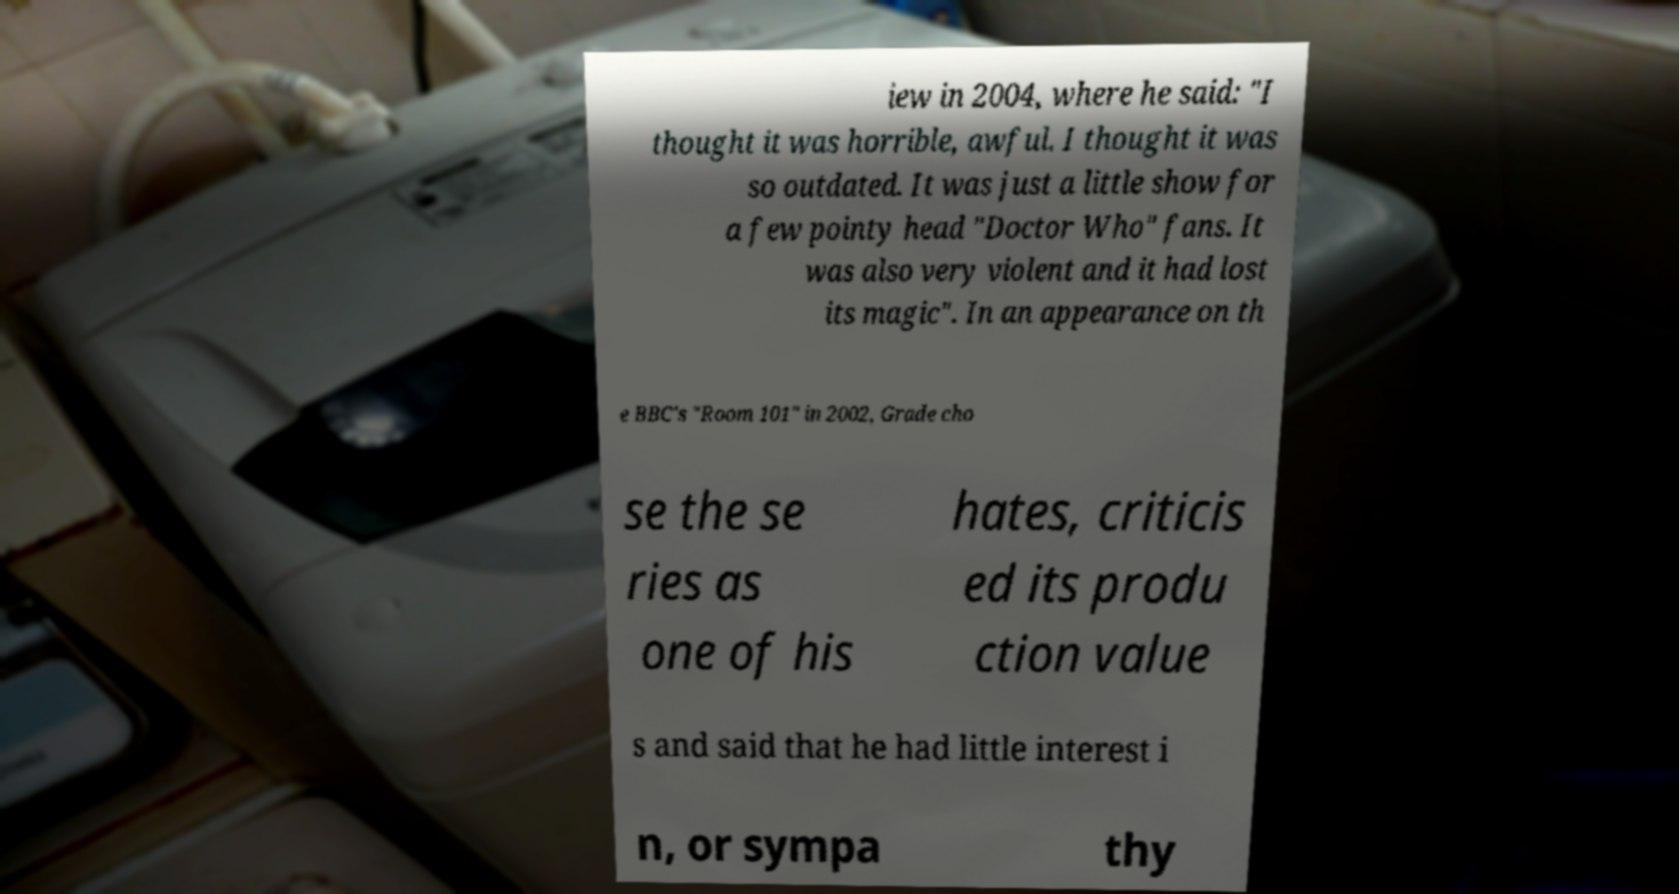Please identify and transcribe the text found in this image. iew in 2004, where he said: "I thought it was horrible, awful. I thought it was so outdated. It was just a little show for a few pointy head "Doctor Who" fans. It was also very violent and it had lost its magic". In an appearance on th e BBC's "Room 101" in 2002, Grade cho se the se ries as one of his hates, criticis ed its produ ction value s and said that he had little interest i n, or sympa thy 